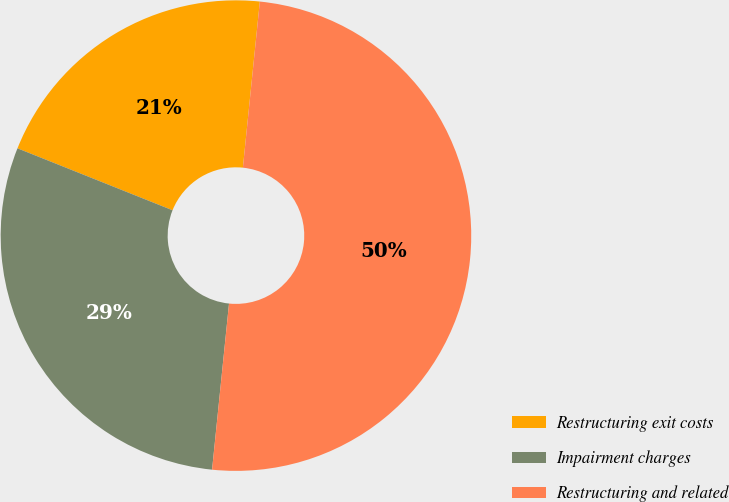Convert chart to OTSL. <chart><loc_0><loc_0><loc_500><loc_500><pie_chart><fcel>Restructuring exit costs<fcel>Impairment charges<fcel>Restructuring and related<nl><fcel>20.57%<fcel>29.43%<fcel>50.0%<nl></chart> 